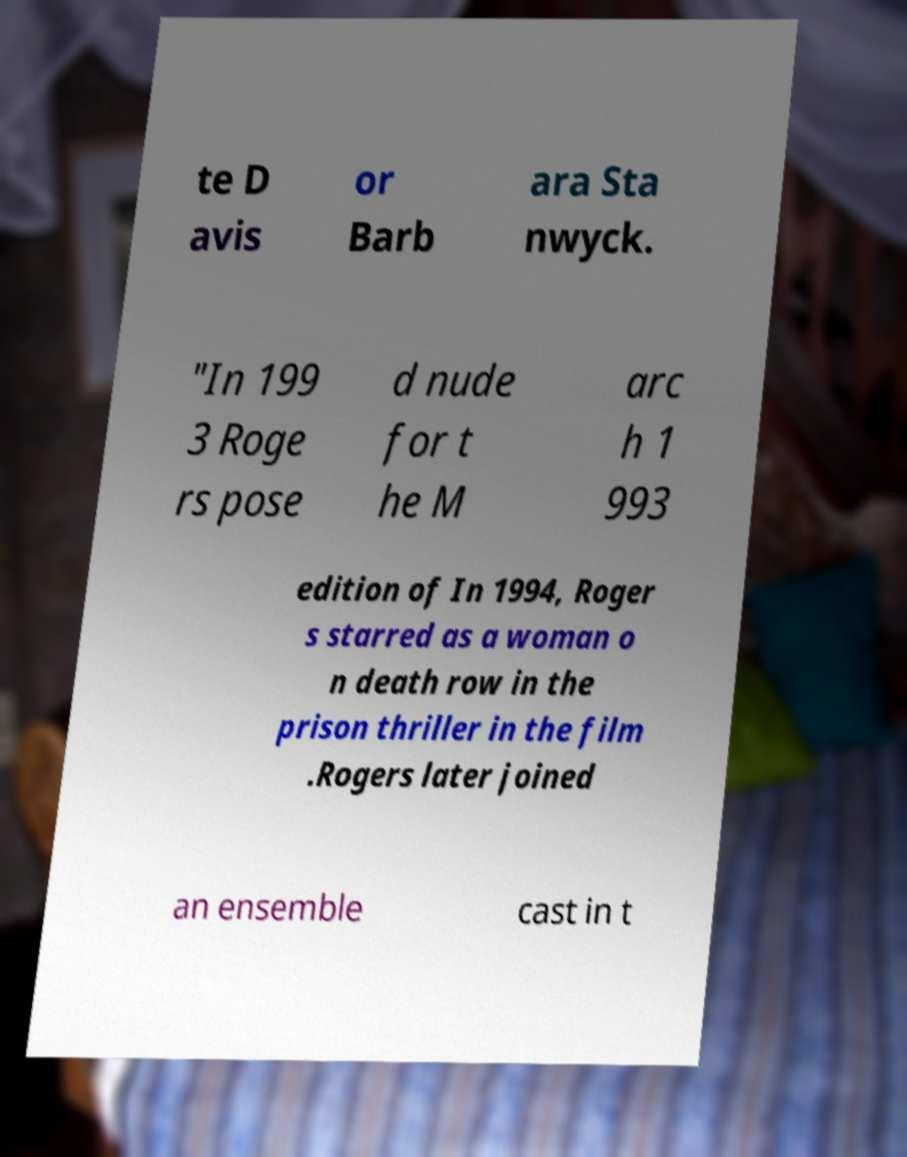Could you extract and type out the text from this image? te D avis or Barb ara Sta nwyck. "In 199 3 Roge rs pose d nude for t he M arc h 1 993 edition of In 1994, Roger s starred as a woman o n death row in the prison thriller in the film .Rogers later joined an ensemble cast in t 